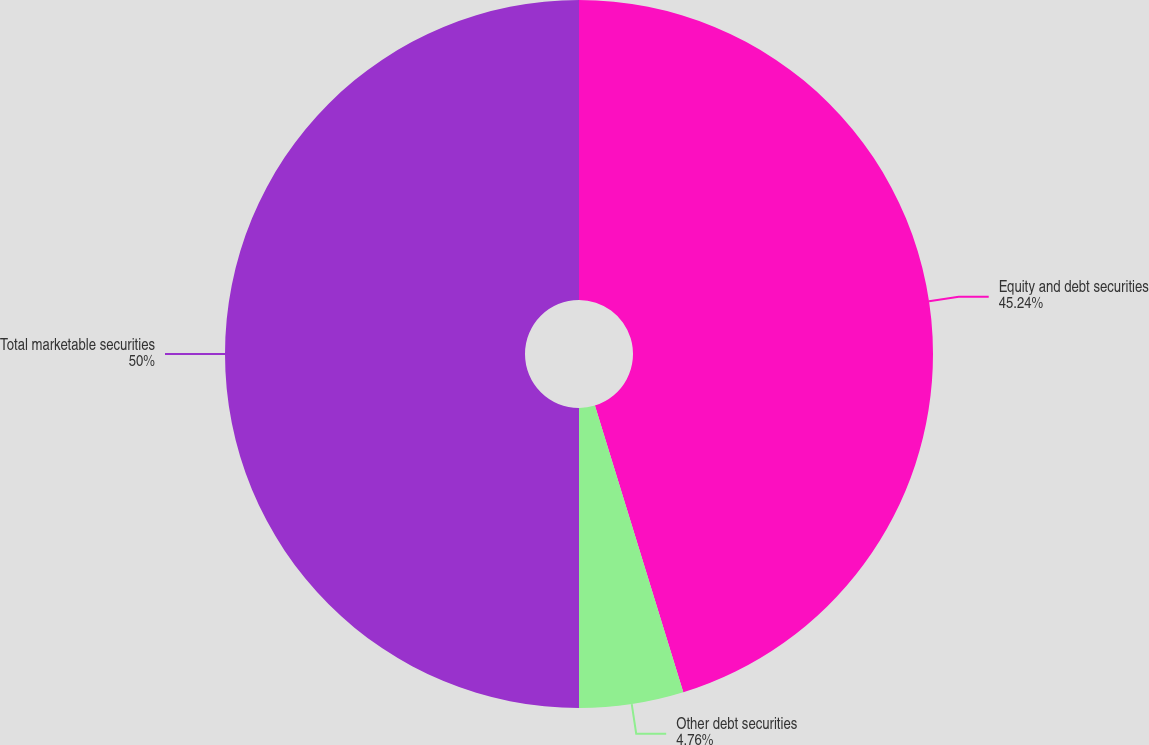Convert chart. <chart><loc_0><loc_0><loc_500><loc_500><pie_chart><fcel>Equity and debt securities<fcel>Other debt securities<fcel>Total marketable securities<nl><fcel>45.24%<fcel>4.76%<fcel>50.0%<nl></chart> 